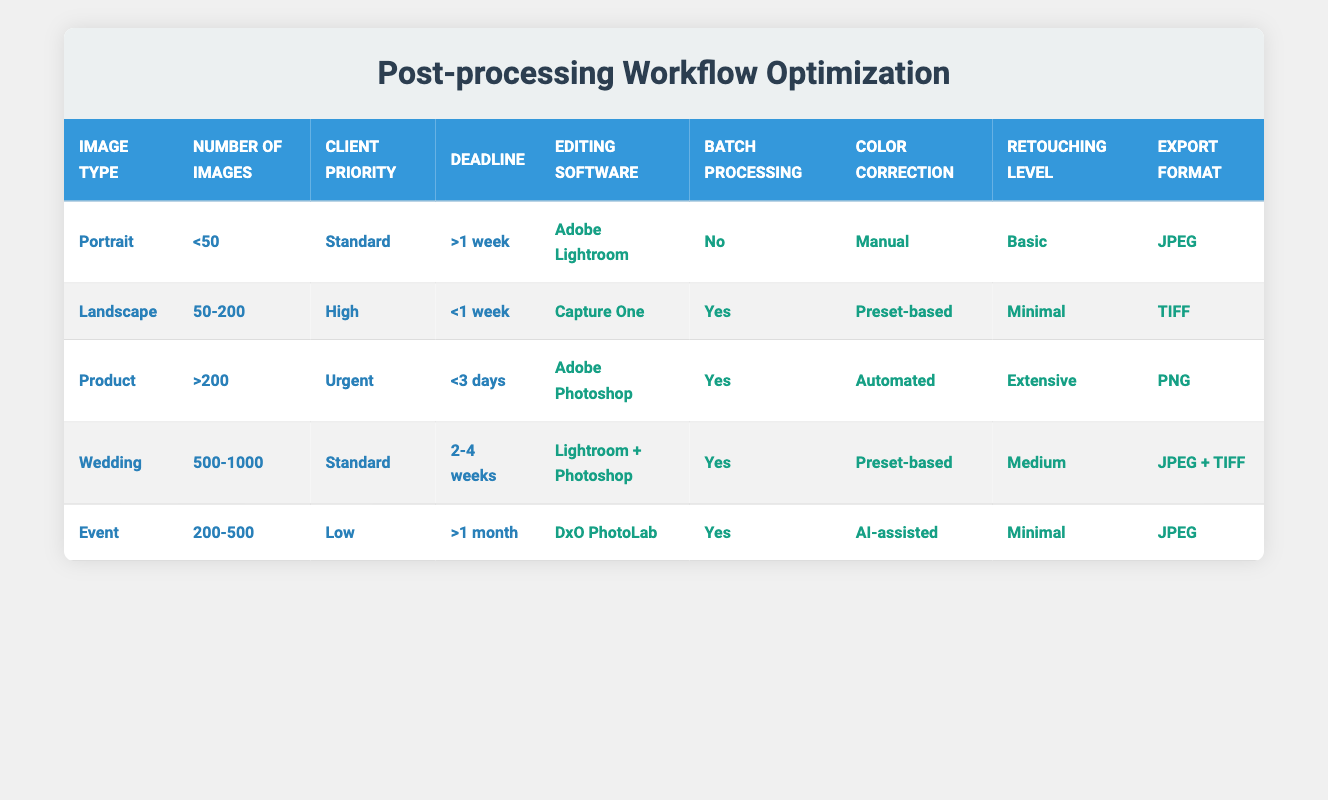What editing software is used for Portrait images? The row corresponding to "Portrait" lists "Adobe Lightroom" under the Editing software column.
Answer: Adobe Lightroom What is the number of images for which Capture One is used? The row with "Capture One" indicates that it is used for "50-200" images in the Number of images column.
Answer: 50-200 Is batch processing utilized for Wedding images? Referring to the Wedding row, it shows "Yes" under the Batch processing column, indicating that batch processing is indeed utilized for Wedding images.
Answer: Yes What is the export format for Product images with an urgent priority? Looking at the Product row, it states "PNG" in the Export format column for images that are over 200 and labeled as urgent.
Answer: PNG How many editing software options are used for images with a Low client priority? The Event row shows that "DxO PhotoLab" is the only editing software listed for low client priority images, meaning there is only one option.
Answer: 1 Which images have a deadline of more than 1 month? The Event row lists "Event" images with a deadline of ">1 month". Therefore, the only image type classified under this deadline is "Event".
Answer: Event What is the difference in the number of images between Portrait and Product types? Portrait type has "<50" images and Product type has ">200" images. Since one type is a limit and the other is only a minimum, we cannot directly calculate a difference. However, we can say Product typically represents at least 201 images, so taking the lower limit of Portrait makes the difference at least 201.
Answer: At least 201 Are automated color correction techniques used for any landscapes? In the Landscape row, it lists "Preset-based" for color correction. Hence, no automated techniques are applied in this case.
Answer: No What is the highest retouching level mentioned in the table? The Product row indicates "Extensive" as the highest retouching level among the different image types.
Answer: Extensive How does the editing software for Wedding images compare to that of Portrait images? Wedding images use "Lightroom + Photoshop" while Portrait images use "Adobe Lightroom". Thus, Wedding images use a combination of two software options, making it more comprehensive than the single software used for Portrait images.
Answer: More comprehensive 